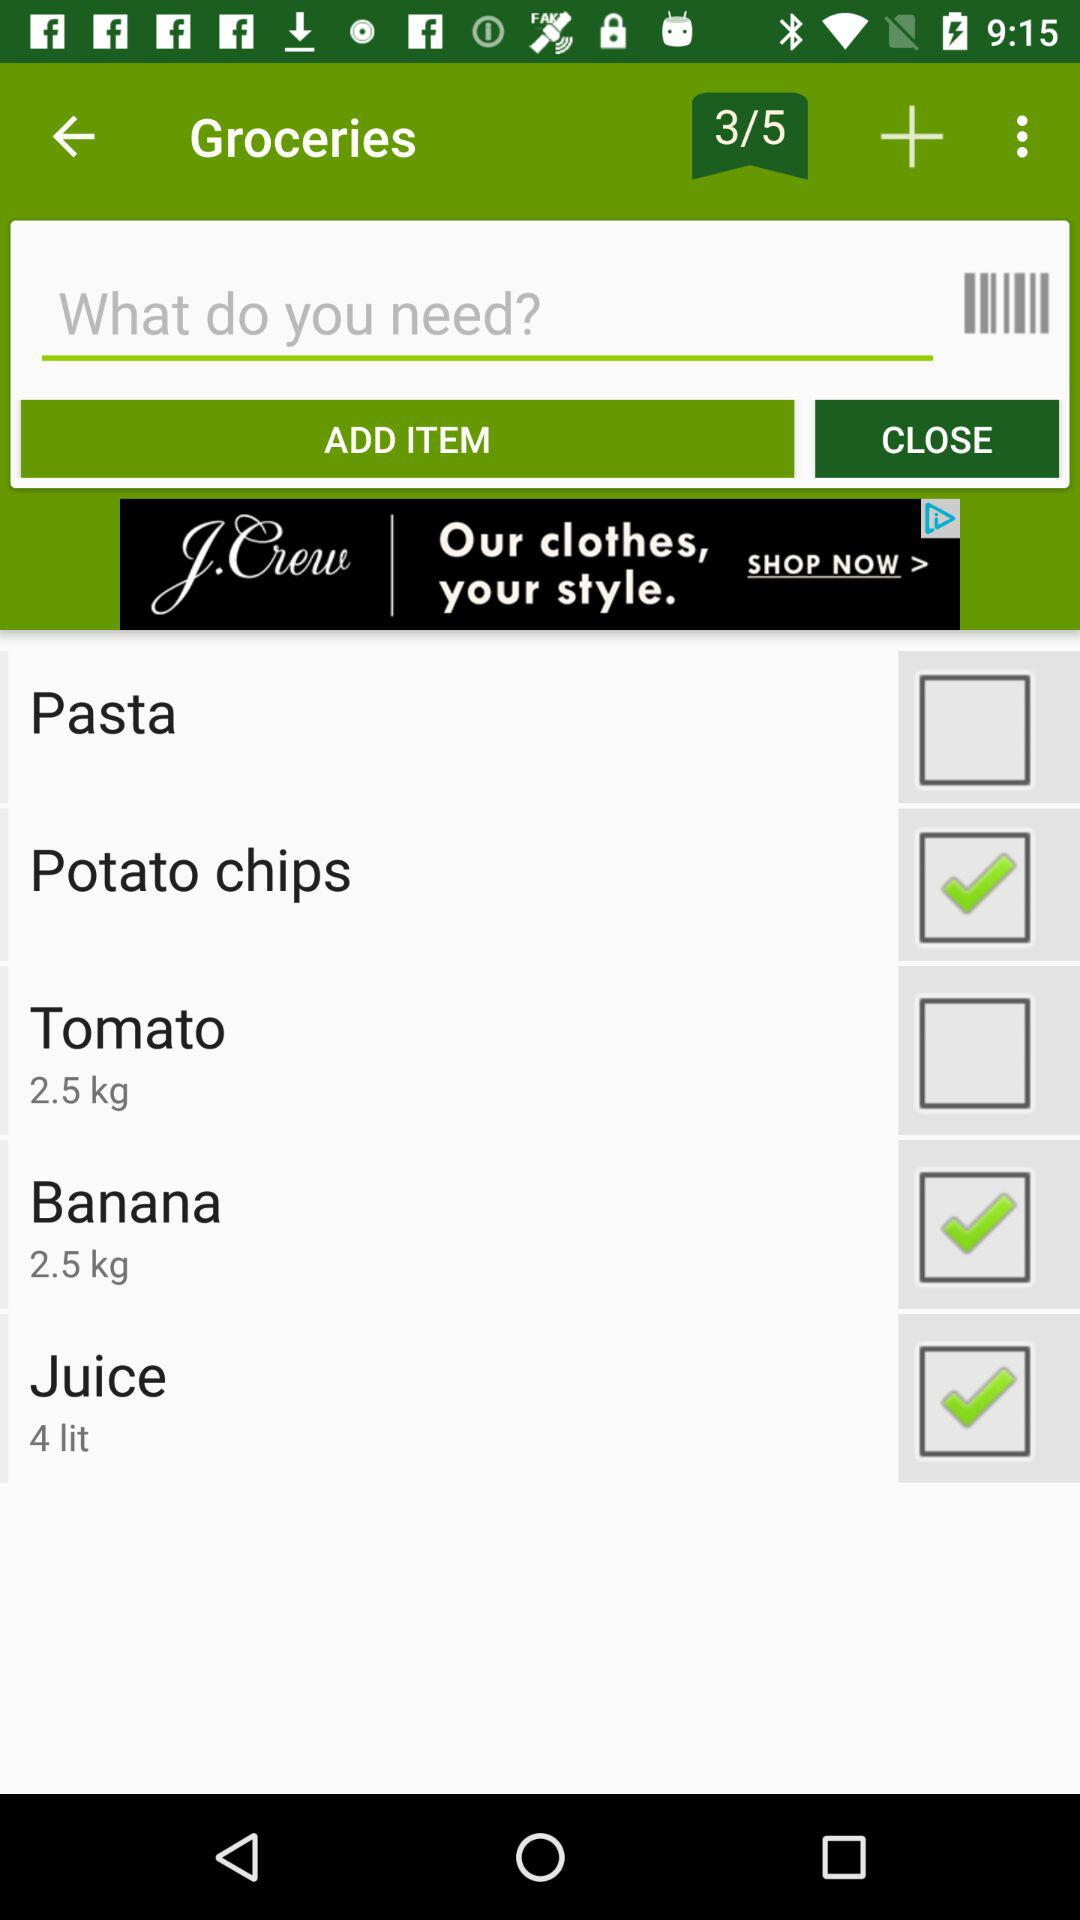How many kilos of tomatoes are mentioned? There are 2.5 kilos of tomatoes. 